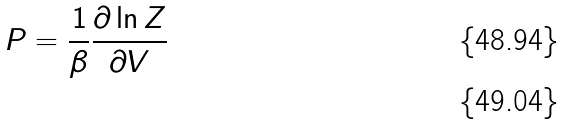<formula> <loc_0><loc_0><loc_500><loc_500>P = \frac { 1 } { \beta } \frac { \partial \ln Z } { \partial V } \\</formula> 